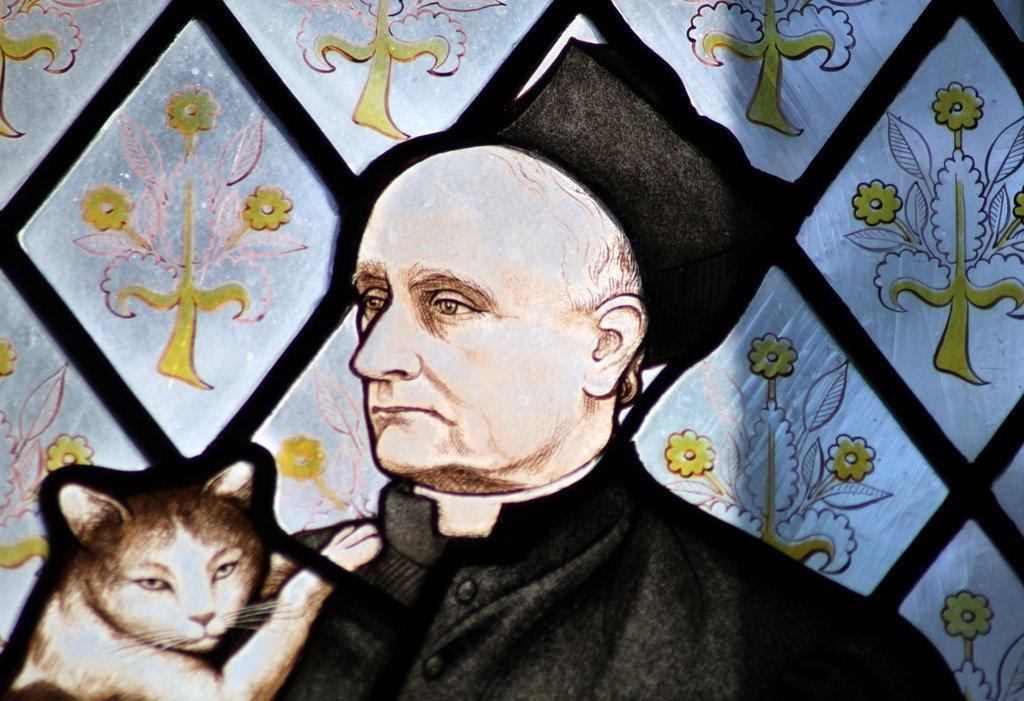Describe this image in one or two sentences. In this image there is a depiction of cat, person and flower. 